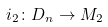Convert formula to latex. <formula><loc_0><loc_0><loc_500><loc_500>i _ { 2 } \colon D _ { n } \rightarrow M _ { 2 }</formula> 